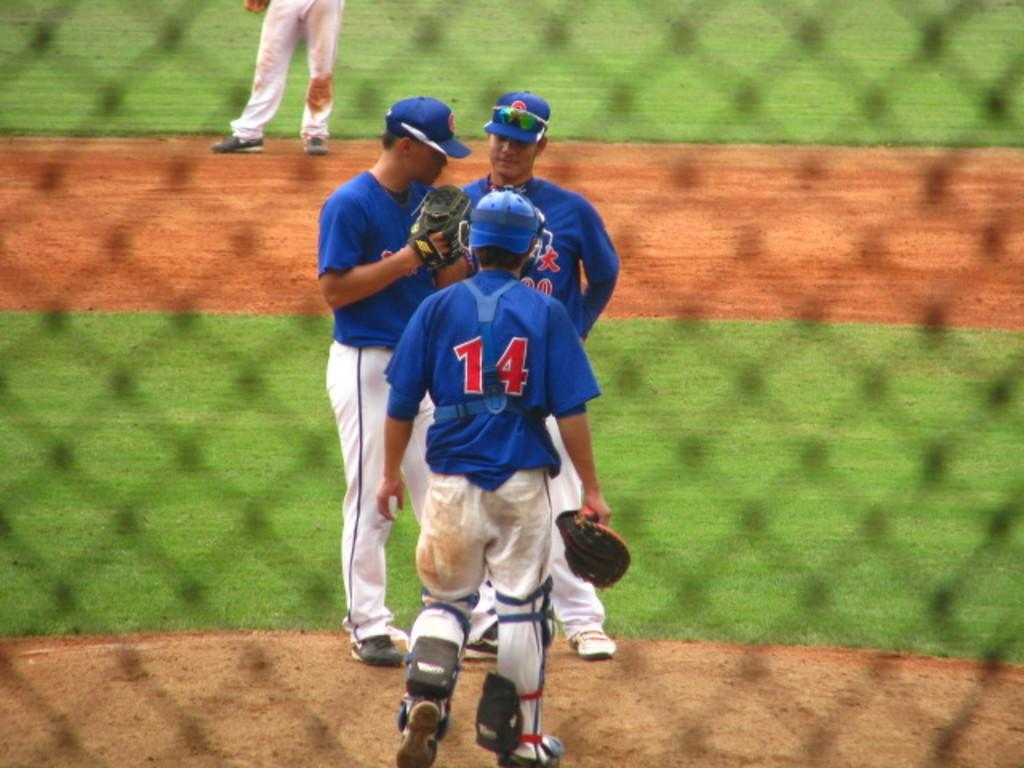<image>
Share a concise interpretation of the image provided. A catcher for a baseball team who wears the number 14 is meeting with the pitcher and coach on the mound. 